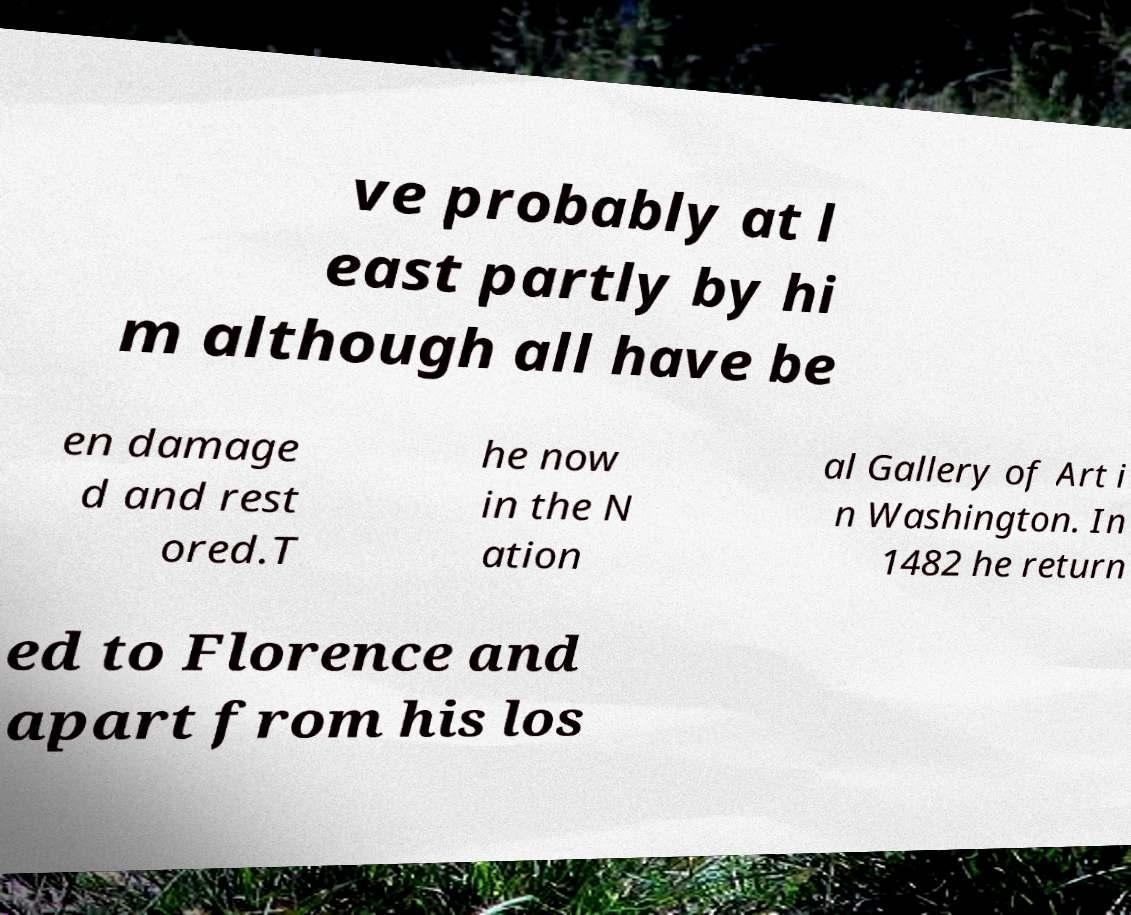Please read and relay the text visible in this image. What does it say? ve probably at l east partly by hi m although all have be en damage d and rest ored.T he now in the N ation al Gallery of Art i n Washington. In 1482 he return ed to Florence and apart from his los 